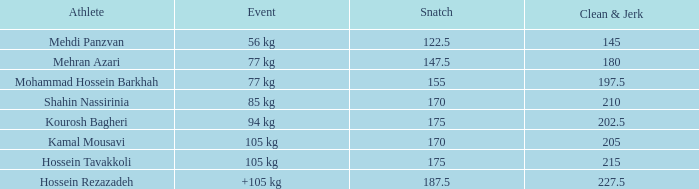What count of snatches results in a sum of 267.5? 0.0. Can you give me this table as a dict? {'header': ['Athlete', 'Event', 'Snatch', 'Clean & Jerk'], 'rows': [['Mehdi Panzvan', '56 kg', '122.5', '145'], ['Mehran Azari', '77 kg', '147.5', '180'], ['Mohammad Hossein Barkhah', '77 kg', '155', '197.5'], ['Shahin Nassirinia', '85 kg', '170', '210'], ['Kourosh Bagheri', '94 kg', '175', '202.5'], ['Kamal Mousavi', '105 kg', '170', '205'], ['Hossein Tavakkoli', '105 kg', '175', '215'], ['Hossein Rezazadeh', '+105 kg', '187.5', '227.5']]} 